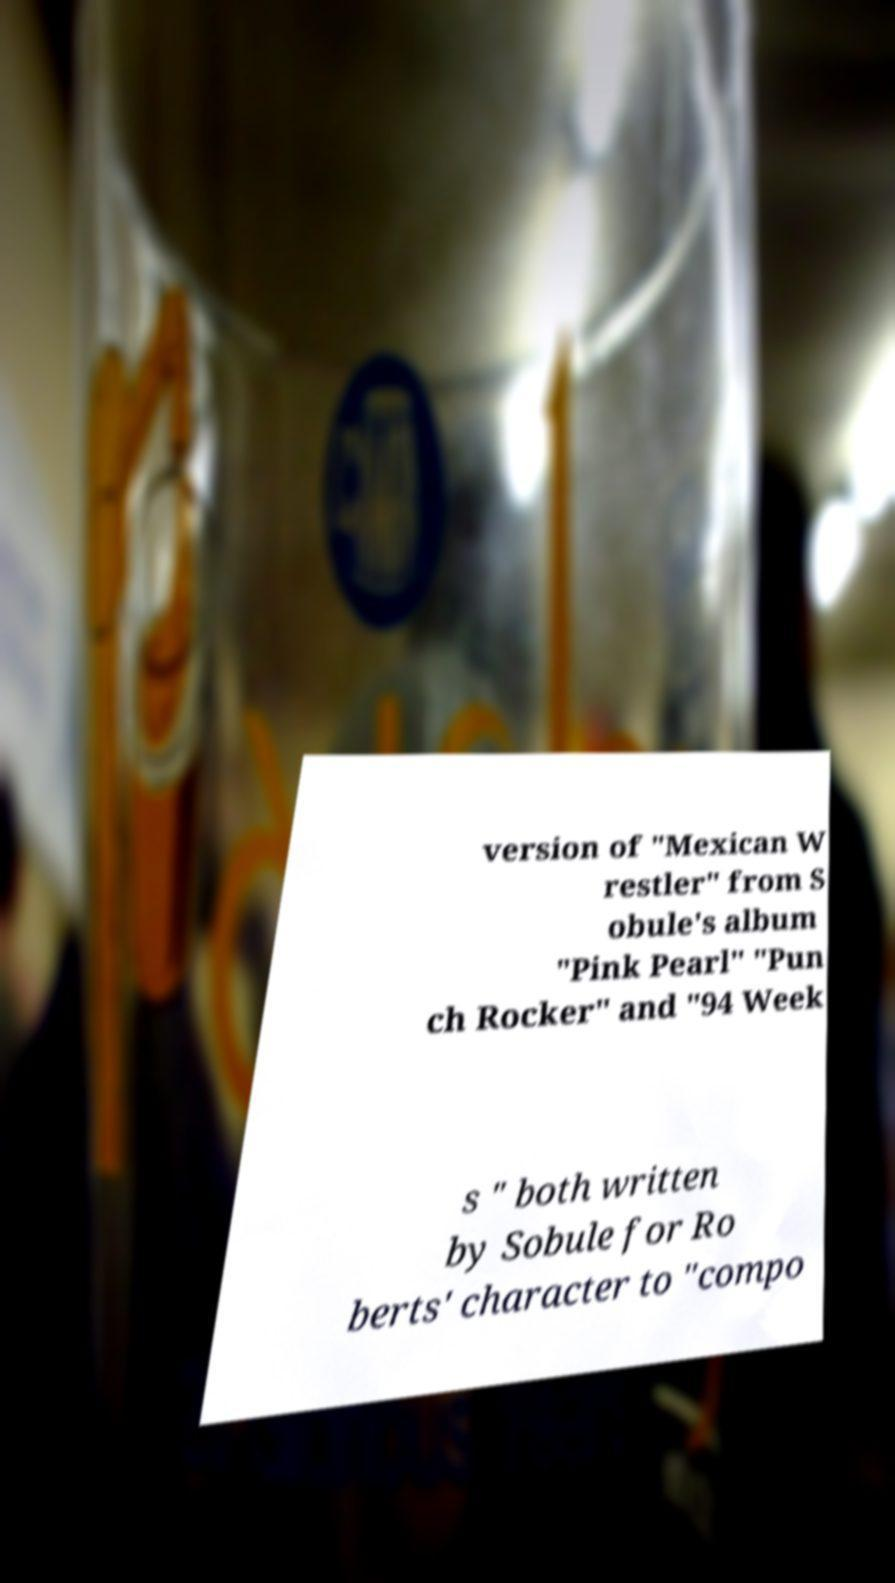Can you read and provide the text displayed in the image?This photo seems to have some interesting text. Can you extract and type it out for me? version of "Mexican W restler" from S obule's album "Pink Pearl" "Pun ch Rocker" and "94 Week s " both written by Sobule for Ro berts' character to "compo 